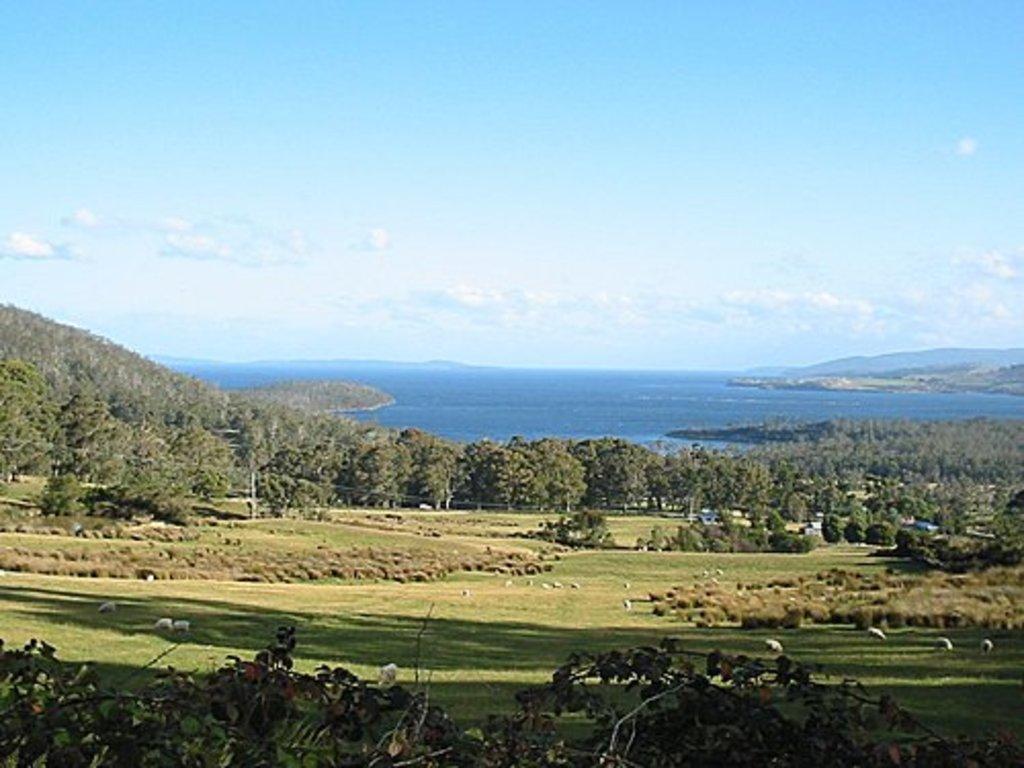Could you give a brief overview of what you see in this image? In this image I can see many trees and in the middle I can see water and in the background I can see the sky and cloud. 